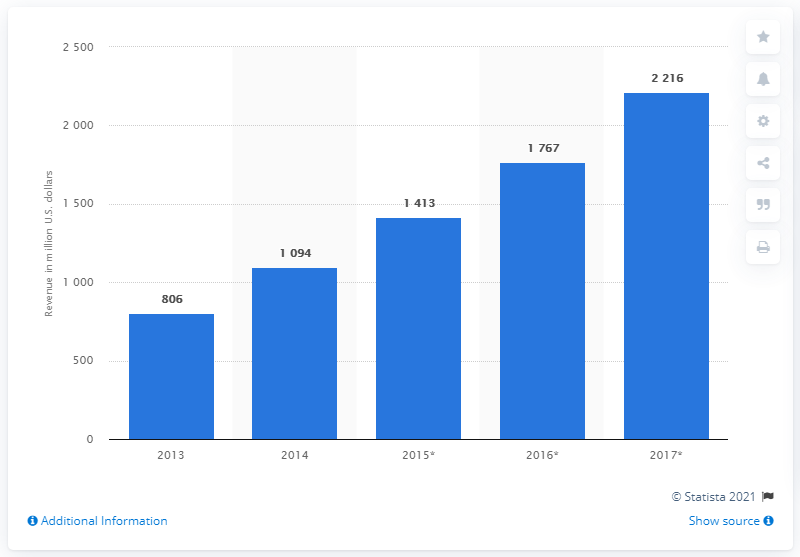Specify some key components in this picture. In 2014, the global gaming market was valued at approximately 1094 billion dollars. It is estimated that the gaming market in Southeast Asia was valued at approximately 2,216 in 2017. 